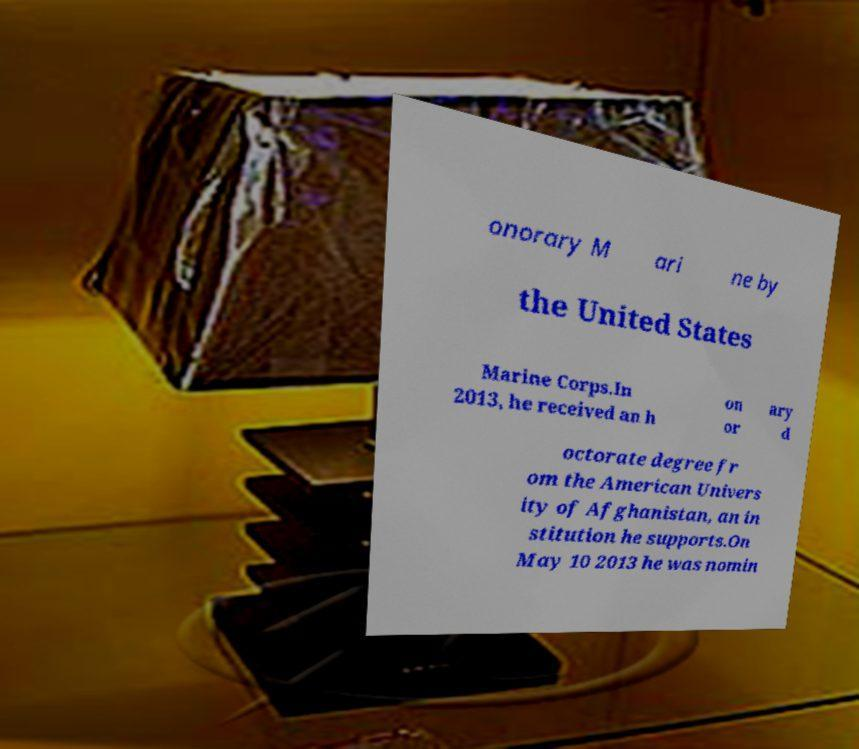Please identify and transcribe the text found in this image. onorary M ari ne by the United States Marine Corps.In 2013, he received an h on or ary d octorate degree fr om the American Univers ity of Afghanistan, an in stitution he supports.On May 10 2013 he was nomin 